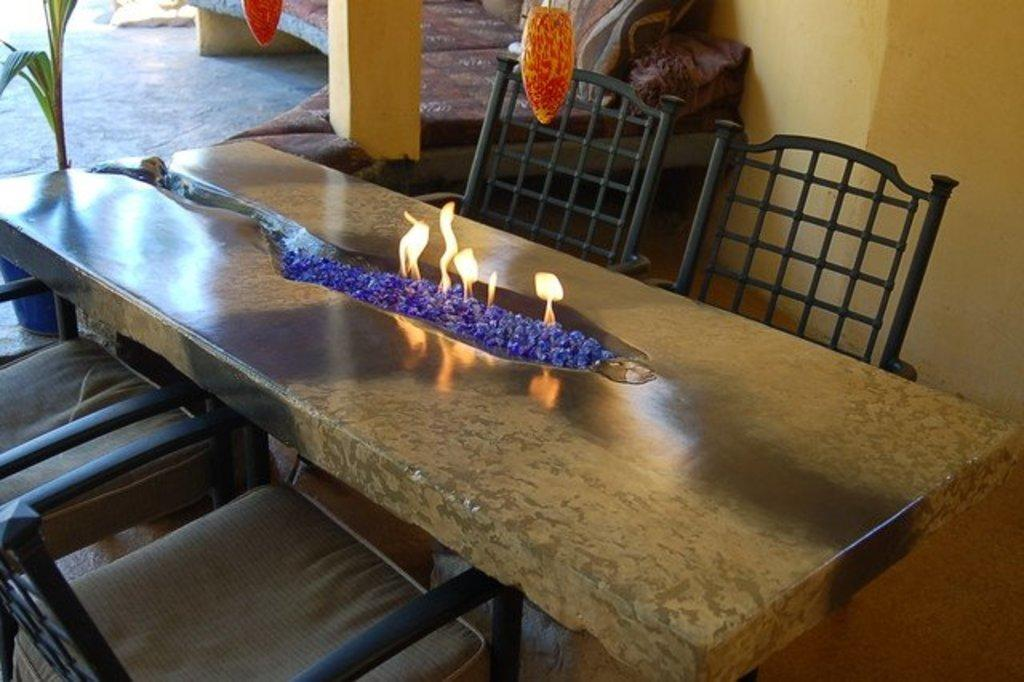What piece of furniture is in the center of the image? There is a table in the image. What is happening between the table? There is fire between the table. How many chairs are positioned around the table? There are two chairs on either side of the table. What can be seen in the background of the image? There is a sofa and other objects visible in the background of the image. What letters are being used to stir the fire in the image? There are no letters present in the image, and they are not being used to stir the fire. What type of house is visible in the background of the image? There is no house visible in the background of the image; only a sofa and other objects can be seen. 